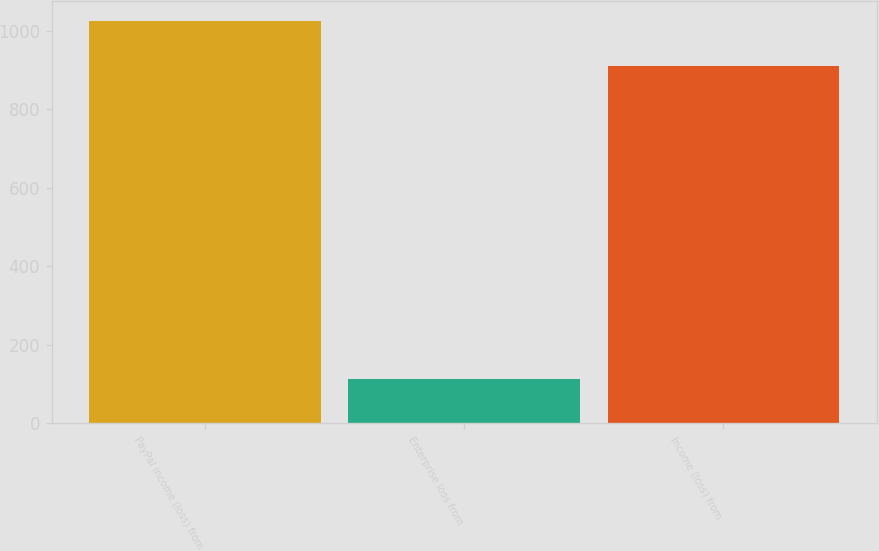Convert chart. <chart><loc_0><loc_0><loc_500><loc_500><bar_chart><fcel>PayPal income (loss) from<fcel>Enterprise loss from<fcel>Income (loss) from<nl><fcel>1024<fcel>113<fcel>911<nl></chart> 